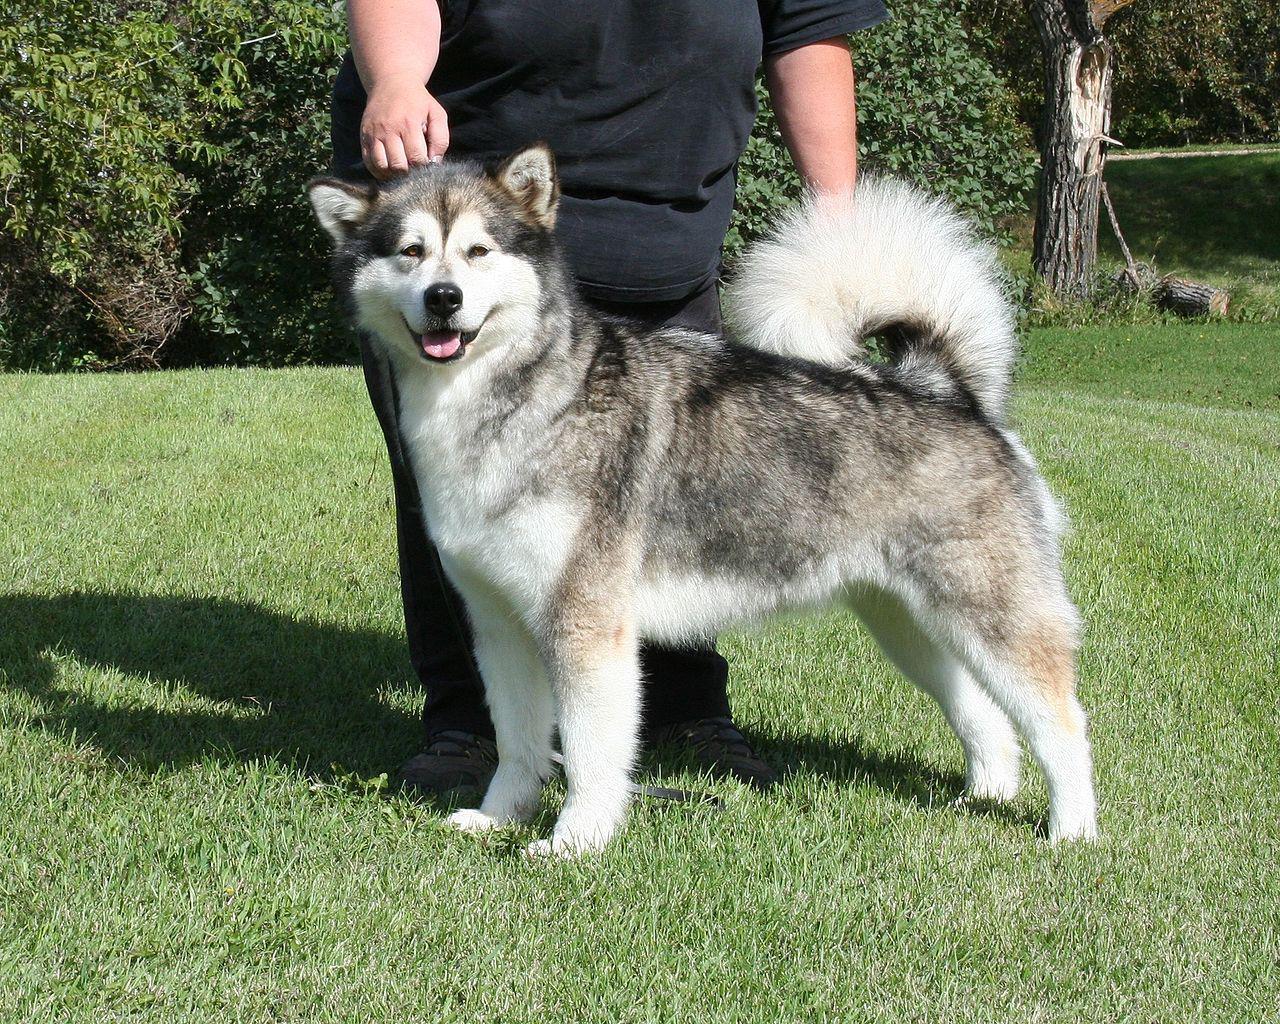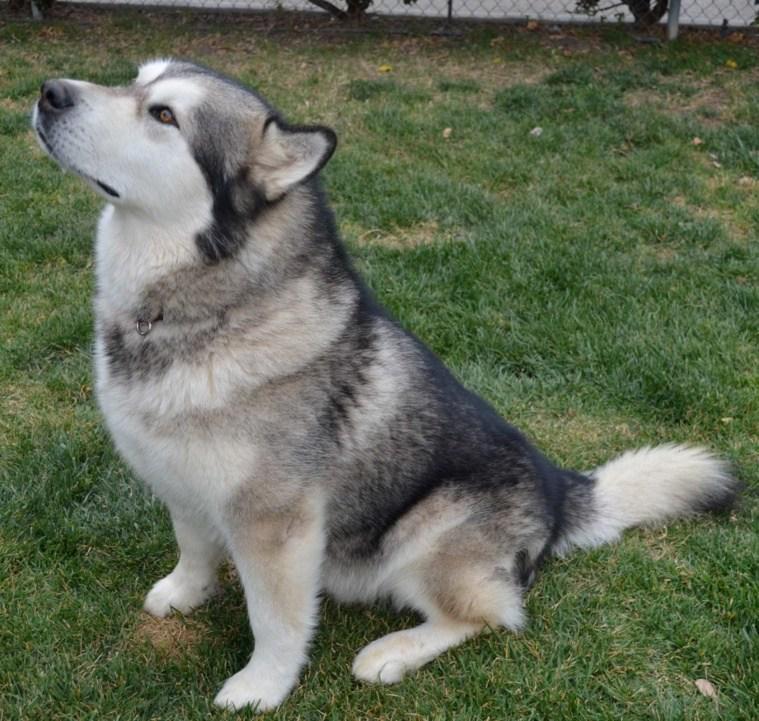The first image is the image on the left, the second image is the image on the right. Given the left and right images, does the statement "Each image contains one dog, and one of the dogs depicted is a husky standing in profile on grass, with white around its eyes and its tail curled inward." hold true? Answer yes or no. Yes. 